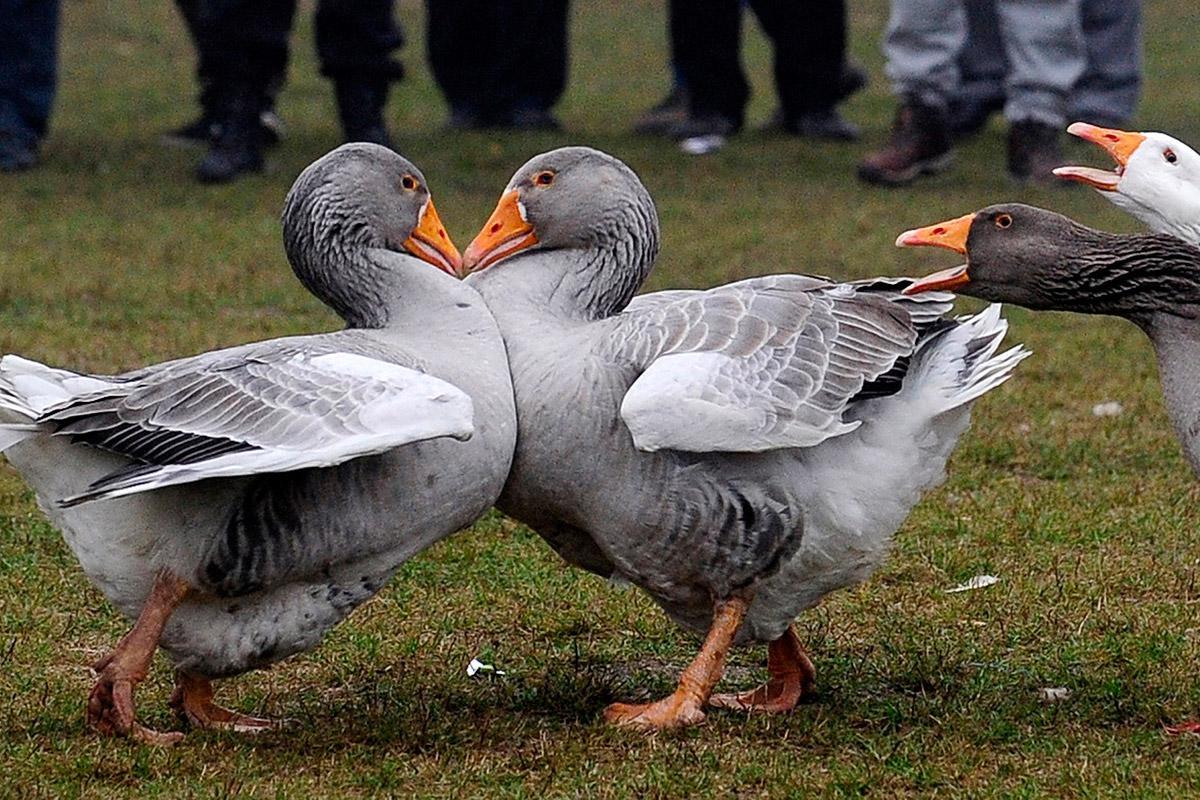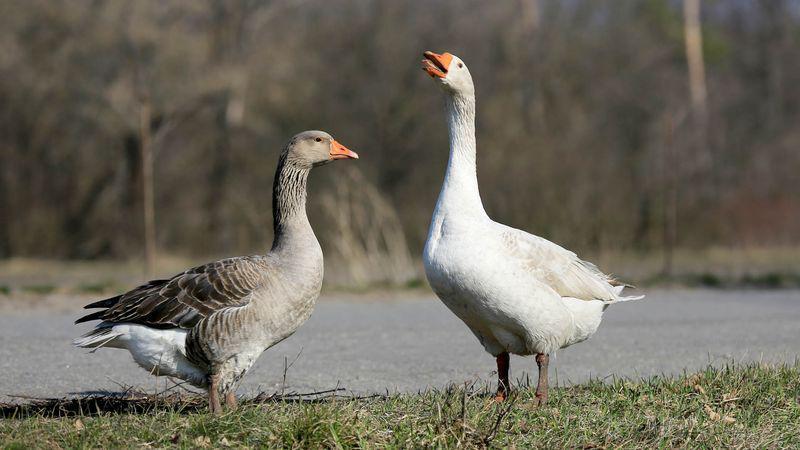The first image is the image on the left, the second image is the image on the right. Analyze the images presented: Is the assertion "At least one image includes two birds standing face to face on dry land in the foreground." valid? Answer yes or no. Yes. The first image is the image on the left, the second image is the image on the right. Assess this claim about the two images: "The birds in the image on the right are near a body of water.". Correct or not? Answer yes or no. Yes. 